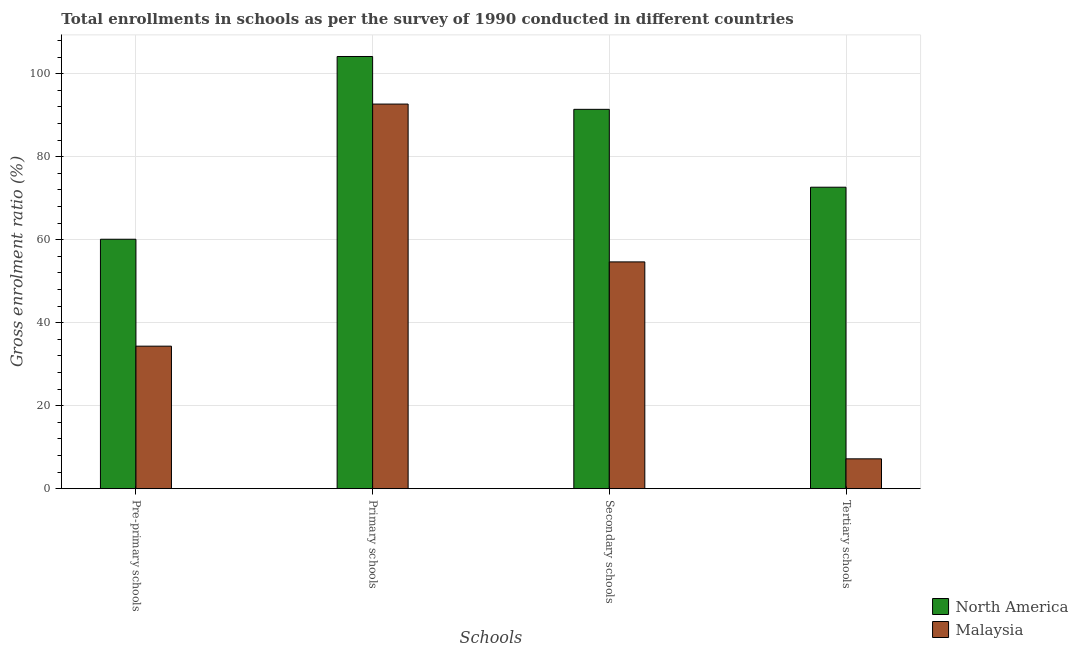How many groups of bars are there?
Make the answer very short. 4. Are the number of bars per tick equal to the number of legend labels?
Your answer should be compact. Yes. Are the number of bars on each tick of the X-axis equal?
Offer a terse response. Yes. How many bars are there on the 3rd tick from the left?
Your response must be concise. 2. What is the label of the 1st group of bars from the left?
Offer a very short reply. Pre-primary schools. What is the gross enrolment ratio in secondary schools in North America?
Make the answer very short. 91.42. Across all countries, what is the maximum gross enrolment ratio in pre-primary schools?
Your answer should be very brief. 60.12. Across all countries, what is the minimum gross enrolment ratio in primary schools?
Provide a succinct answer. 92.69. In which country was the gross enrolment ratio in secondary schools minimum?
Your response must be concise. Malaysia. What is the total gross enrolment ratio in tertiary schools in the graph?
Provide a succinct answer. 79.85. What is the difference between the gross enrolment ratio in pre-primary schools in Malaysia and that in North America?
Make the answer very short. -25.77. What is the difference between the gross enrolment ratio in tertiary schools in North America and the gross enrolment ratio in secondary schools in Malaysia?
Provide a succinct answer. 18. What is the average gross enrolment ratio in primary schools per country?
Offer a very short reply. 98.43. What is the difference between the gross enrolment ratio in primary schools and gross enrolment ratio in secondary schools in Malaysia?
Offer a very short reply. 38.04. What is the ratio of the gross enrolment ratio in secondary schools in Malaysia to that in North America?
Provide a short and direct response. 0.6. What is the difference between the highest and the second highest gross enrolment ratio in tertiary schools?
Provide a succinct answer. 65.47. What is the difference between the highest and the lowest gross enrolment ratio in primary schools?
Give a very brief answer. 11.47. Is the sum of the gross enrolment ratio in pre-primary schools in Malaysia and North America greater than the maximum gross enrolment ratio in primary schools across all countries?
Your answer should be compact. No. What does the 2nd bar from the left in Secondary schools represents?
Provide a succinct answer. Malaysia. What does the 2nd bar from the right in Secondary schools represents?
Ensure brevity in your answer.  North America. How many bars are there?
Your response must be concise. 8. Are all the bars in the graph horizontal?
Your answer should be very brief. No. How many countries are there in the graph?
Ensure brevity in your answer.  2. What is the difference between two consecutive major ticks on the Y-axis?
Your answer should be compact. 20. Are the values on the major ticks of Y-axis written in scientific E-notation?
Give a very brief answer. No. Does the graph contain grids?
Keep it short and to the point. Yes. Where does the legend appear in the graph?
Your answer should be very brief. Bottom right. How are the legend labels stacked?
Your answer should be compact. Vertical. What is the title of the graph?
Your response must be concise. Total enrollments in schools as per the survey of 1990 conducted in different countries. Does "Norway" appear as one of the legend labels in the graph?
Give a very brief answer. No. What is the label or title of the X-axis?
Offer a terse response. Schools. What is the label or title of the Y-axis?
Make the answer very short. Gross enrolment ratio (%). What is the Gross enrolment ratio (%) in North America in Pre-primary schools?
Provide a succinct answer. 60.12. What is the Gross enrolment ratio (%) in Malaysia in Pre-primary schools?
Give a very brief answer. 34.35. What is the Gross enrolment ratio (%) in North America in Primary schools?
Your answer should be compact. 104.16. What is the Gross enrolment ratio (%) of Malaysia in Primary schools?
Keep it short and to the point. 92.69. What is the Gross enrolment ratio (%) in North America in Secondary schools?
Give a very brief answer. 91.42. What is the Gross enrolment ratio (%) in Malaysia in Secondary schools?
Provide a succinct answer. 54.66. What is the Gross enrolment ratio (%) in North America in Tertiary schools?
Ensure brevity in your answer.  72.66. What is the Gross enrolment ratio (%) of Malaysia in Tertiary schools?
Keep it short and to the point. 7.19. Across all Schools, what is the maximum Gross enrolment ratio (%) of North America?
Ensure brevity in your answer.  104.16. Across all Schools, what is the maximum Gross enrolment ratio (%) of Malaysia?
Your response must be concise. 92.69. Across all Schools, what is the minimum Gross enrolment ratio (%) in North America?
Ensure brevity in your answer.  60.12. Across all Schools, what is the minimum Gross enrolment ratio (%) in Malaysia?
Offer a very short reply. 7.19. What is the total Gross enrolment ratio (%) in North America in the graph?
Offer a terse response. 328.36. What is the total Gross enrolment ratio (%) of Malaysia in the graph?
Ensure brevity in your answer.  188.88. What is the difference between the Gross enrolment ratio (%) of North America in Pre-primary schools and that in Primary schools?
Keep it short and to the point. -44.04. What is the difference between the Gross enrolment ratio (%) in Malaysia in Pre-primary schools and that in Primary schools?
Your response must be concise. -58.35. What is the difference between the Gross enrolment ratio (%) in North America in Pre-primary schools and that in Secondary schools?
Offer a very short reply. -31.31. What is the difference between the Gross enrolment ratio (%) of Malaysia in Pre-primary schools and that in Secondary schools?
Provide a succinct answer. -20.31. What is the difference between the Gross enrolment ratio (%) in North America in Pre-primary schools and that in Tertiary schools?
Keep it short and to the point. -12.54. What is the difference between the Gross enrolment ratio (%) in Malaysia in Pre-primary schools and that in Tertiary schools?
Your answer should be compact. 27.16. What is the difference between the Gross enrolment ratio (%) of North America in Primary schools and that in Secondary schools?
Give a very brief answer. 12.74. What is the difference between the Gross enrolment ratio (%) in Malaysia in Primary schools and that in Secondary schools?
Provide a succinct answer. 38.04. What is the difference between the Gross enrolment ratio (%) in North America in Primary schools and that in Tertiary schools?
Your answer should be very brief. 31.5. What is the difference between the Gross enrolment ratio (%) in Malaysia in Primary schools and that in Tertiary schools?
Give a very brief answer. 85.5. What is the difference between the Gross enrolment ratio (%) in North America in Secondary schools and that in Tertiary schools?
Make the answer very short. 18.77. What is the difference between the Gross enrolment ratio (%) of Malaysia in Secondary schools and that in Tertiary schools?
Keep it short and to the point. 47.47. What is the difference between the Gross enrolment ratio (%) of North America in Pre-primary schools and the Gross enrolment ratio (%) of Malaysia in Primary schools?
Provide a succinct answer. -32.58. What is the difference between the Gross enrolment ratio (%) in North America in Pre-primary schools and the Gross enrolment ratio (%) in Malaysia in Secondary schools?
Your answer should be very brief. 5.46. What is the difference between the Gross enrolment ratio (%) in North America in Pre-primary schools and the Gross enrolment ratio (%) in Malaysia in Tertiary schools?
Ensure brevity in your answer.  52.93. What is the difference between the Gross enrolment ratio (%) of North America in Primary schools and the Gross enrolment ratio (%) of Malaysia in Secondary schools?
Make the answer very short. 49.5. What is the difference between the Gross enrolment ratio (%) in North America in Primary schools and the Gross enrolment ratio (%) in Malaysia in Tertiary schools?
Make the answer very short. 96.97. What is the difference between the Gross enrolment ratio (%) in North America in Secondary schools and the Gross enrolment ratio (%) in Malaysia in Tertiary schools?
Your answer should be compact. 84.23. What is the average Gross enrolment ratio (%) of North America per Schools?
Make the answer very short. 82.09. What is the average Gross enrolment ratio (%) in Malaysia per Schools?
Offer a very short reply. 47.22. What is the difference between the Gross enrolment ratio (%) of North America and Gross enrolment ratio (%) of Malaysia in Pre-primary schools?
Your answer should be very brief. 25.77. What is the difference between the Gross enrolment ratio (%) of North America and Gross enrolment ratio (%) of Malaysia in Primary schools?
Provide a succinct answer. 11.47. What is the difference between the Gross enrolment ratio (%) of North America and Gross enrolment ratio (%) of Malaysia in Secondary schools?
Provide a succinct answer. 36.77. What is the difference between the Gross enrolment ratio (%) of North America and Gross enrolment ratio (%) of Malaysia in Tertiary schools?
Provide a short and direct response. 65.47. What is the ratio of the Gross enrolment ratio (%) of North America in Pre-primary schools to that in Primary schools?
Give a very brief answer. 0.58. What is the ratio of the Gross enrolment ratio (%) of Malaysia in Pre-primary schools to that in Primary schools?
Keep it short and to the point. 0.37. What is the ratio of the Gross enrolment ratio (%) in North America in Pre-primary schools to that in Secondary schools?
Your response must be concise. 0.66. What is the ratio of the Gross enrolment ratio (%) of Malaysia in Pre-primary schools to that in Secondary schools?
Ensure brevity in your answer.  0.63. What is the ratio of the Gross enrolment ratio (%) of North America in Pre-primary schools to that in Tertiary schools?
Make the answer very short. 0.83. What is the ratio of the Gross enrolment ratio (%) in Malaysia in Pre-primary schools to that in Tertiary schools?
Provide a succinct answer. 4.78. What is the ratio of the Gross enrolment ratio (%) of North America in Primary schools to that in Secondary schools?
Give a very brief answer. 1.14. What is the ratio of the Gross enrolment ratio (%) of Malaysia in Primary schools to that in Secondary schools?
Ensure brevity in your answer.  1.7. What is the ratio of the Gross enrolment ratio (%) of North America in Primary schools to that in Tertiary schools?
Keep it short and to the point. 1.43. What is the ratio of the Gross enrolment ratio (%) of Malaysia in Primary schools to that in Tertiary schools?
Offer a terse response. 12.89. What is the ratio of the Gross enrolment ratio (%) in North America in Secondary schools to that in Tertiary schools?
Offer a terse response. 1.26. What is the ratio of the Gross enrolment ratio (%) in Malaysia in Secondary schools to that in Tertiary schools?
Offer a terse response. 7.6. What is the difference between the highest and the second highest Gross enrolment ratio (%) of North America?
Give a very brief answer. 12.74. What is the difference between the highest and the second highest Gross enrolment ratio (%) of Malaysia?
Provide a short and direct response. 38.04. What is the difference between the highest and the lowest Gross enrolment ratio (%) of North America?
Give a very brief answer. 44.04. What is the difference between the highest and the lowest Gross enrolment ratio (%) in Malaysia?
Keep it short and to the point. 85.5. 